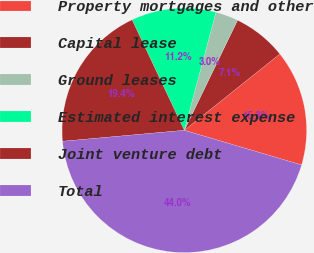Convert chart. <chart><loc_0><loc_0><loc_500><loc_500><pie_chart><fcel>Property mortgages and other<fcel>Capital lease<fcel>Ground leases<fcel>Estimated interest expense<fcel>Joint venture debt<fcel>Total<nl><fcel>15.3%<fcel>7.1%<fcel>3.0%<fcel>11.2%<fcel>19.4%<fcel>44.0%<nl></chart> 